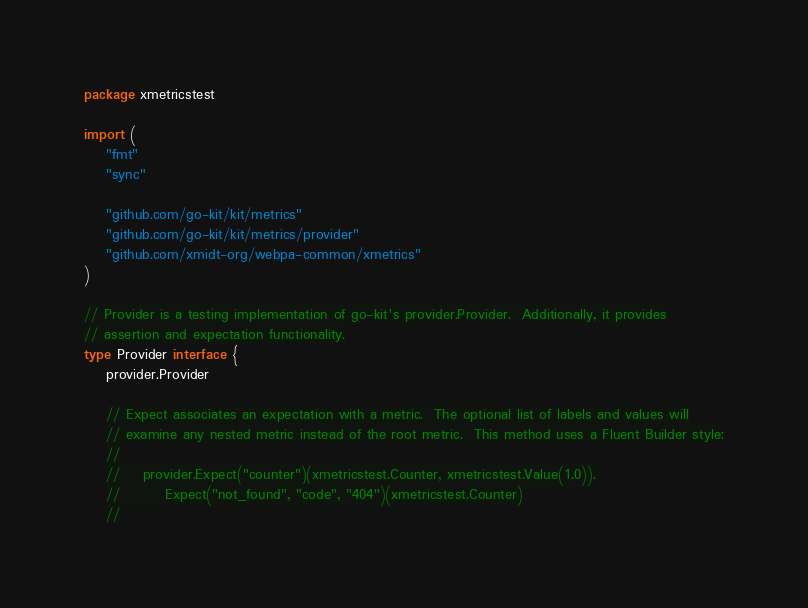<code> <loc_0><loc_0><loc_500><loc_500><_Go_>package xmetricstest

import (
	"fmt"
	"sync"

	"github.com/go-kit/kit/metrics"
	"github.com/go-kit/kit/metrics/provider"
	"github.com/xmidt-org/webpa-common/xmetrics"
)

// Provider is a testing implementation of go-kit's provider.Provider.  Additionally, it provides
// assertion and expectation functionality.
type Provider interface {
	provider.Provider

	// Expect associates an expectation with a metric.  The optional list of labels and values will
	// examine any nested metric instead of the root metric.  This method uses a Fluent Builder style:
	//
	//    provider.Expect("counter")(xmetricstest.Counter, xmetricstest.Value(1.0)).
	//        Expect("not_found", "code", "404")(xmetricstest.Counter)
	//</code> 